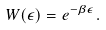<formula> <loc_0><loc_0><loc_500><loc_500>W ( \epsilon ) = e ^ { - \beta \epsilon } .</formula> 